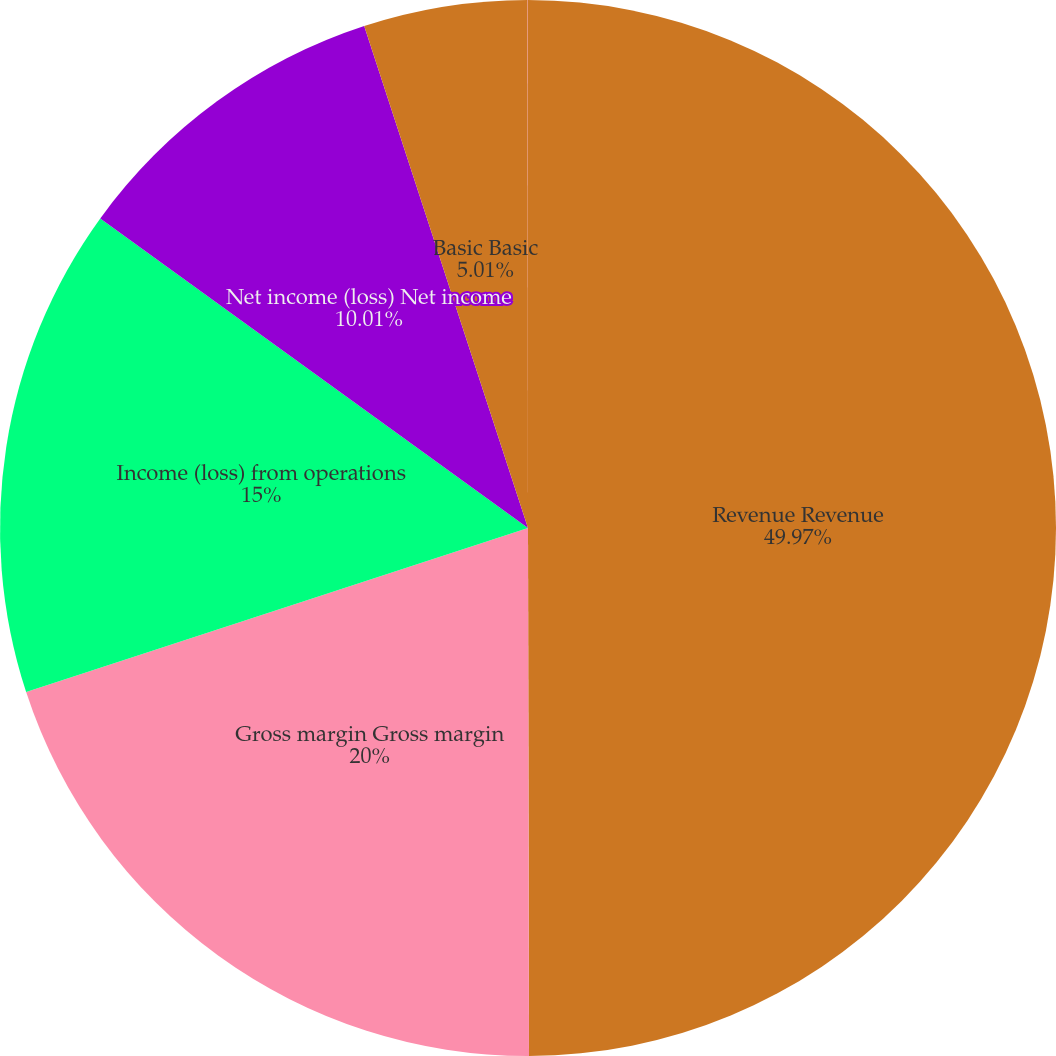Convert chart to OTSL. <chart><loc_0><loc_0><loc_500><loc_500><pie_chart><fcel>Revenue Revenue<fcel>Gross margin Gross margin<fcel>Income (loss) from operations<fcel>Net income (loss) Net income<fcel>Basic Basic<fcel>Diluted Diluted<nl><fcel>49.97%<fcel>20.0%<fcel>15.0%<fcel>10.01%<fcel>5.01%<fcel>0.01%<nl></chart> 